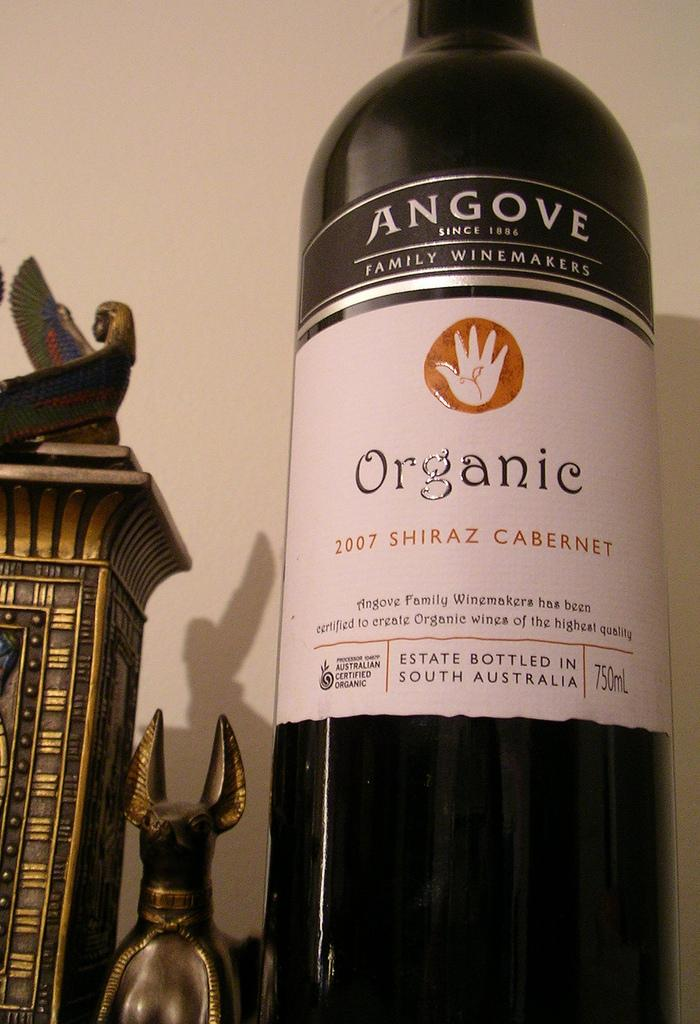<image>
Present a compact description of the photo's key features. Bottle with a white label that says Organic on it. 